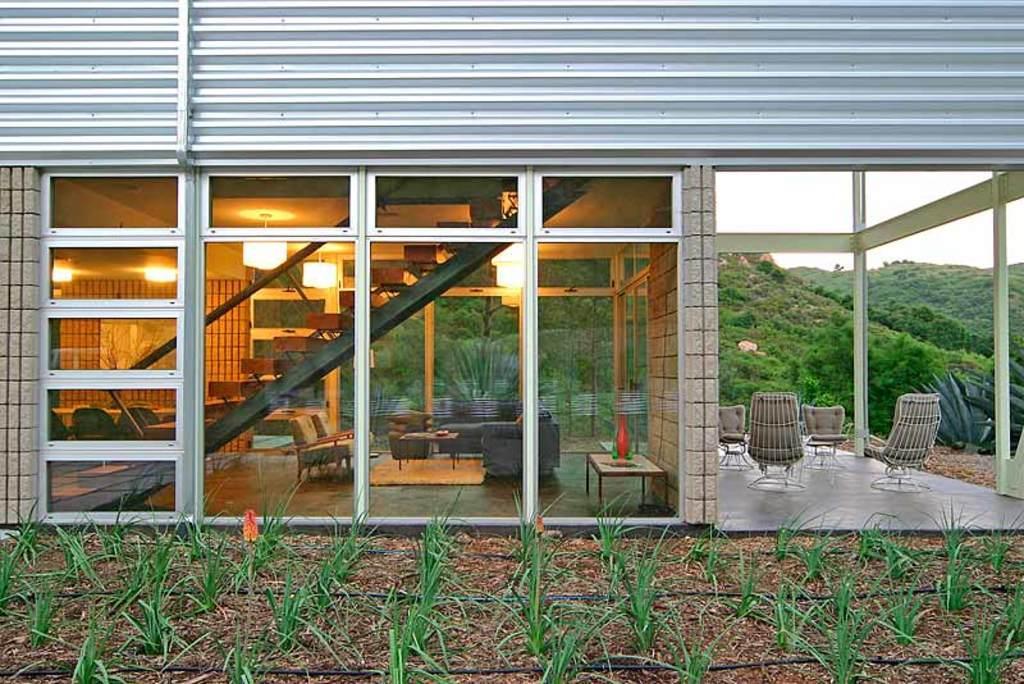Could you give a brief overview of what you see in this image? In the picture we can see a house building with glass walls and inside we can see steps, and some chairs, tables and to the ceiling we can see lights and outside the house we can see some chairs on the path and beside the house we can see some plants on the muddy path and in the background we can see a hill with plants, and trees and sky behind it. 